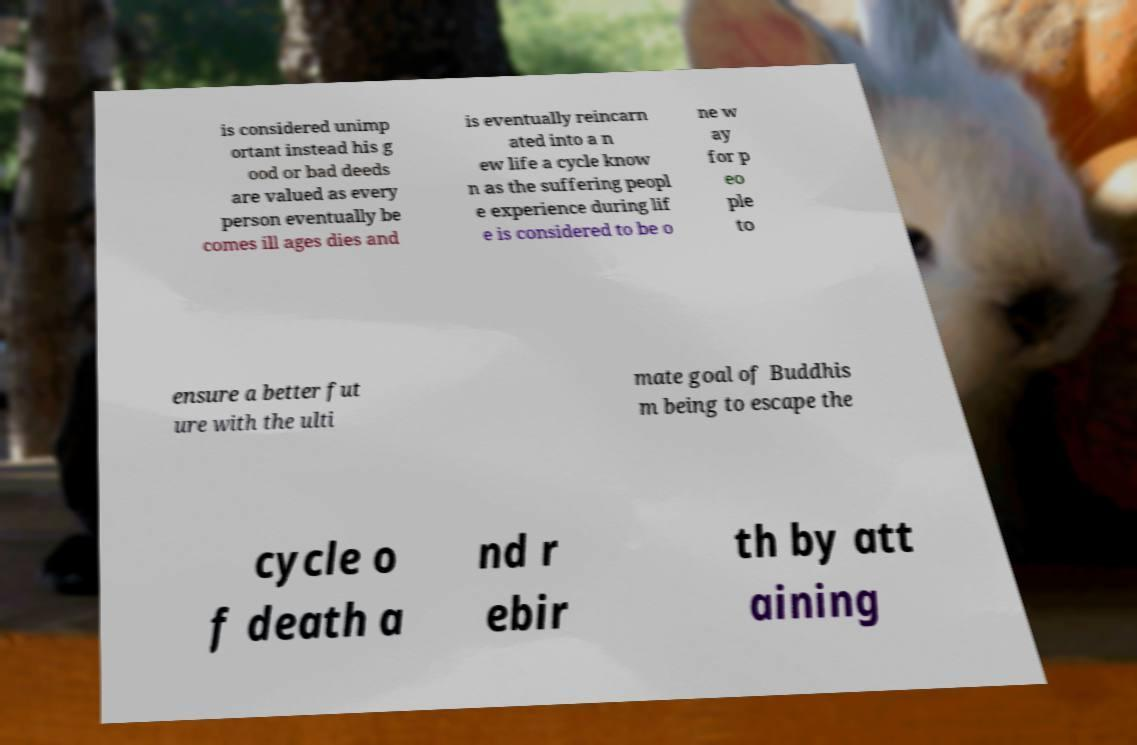Please identify and transcribe the text found in this image. is considered unimp ortant instead his g ood or bad deeds are valued as every person eventually be comes ill ages dies and is eventually reincarn ated into a n ew life a cycle know n as the suffering peopl e experience during lif e is considered to be o ne w ay for p eo ple to ensure a better fut ure with the ulti mate goal of Buddhis m being to escape the cycle o f death a nd r ebir th by att aining 